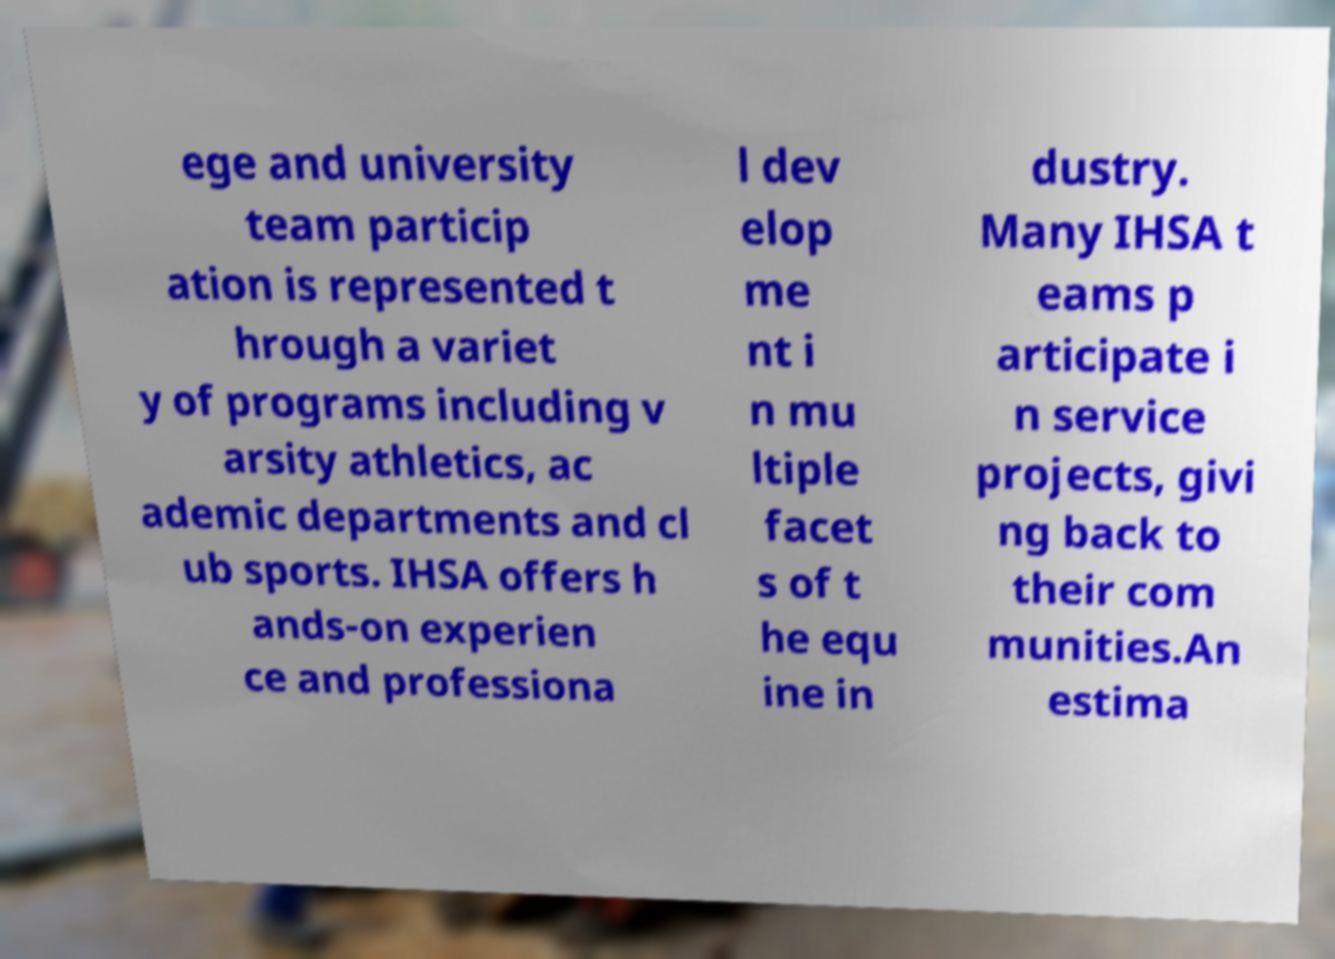Could you extract and type out the text from this image? ege and university team particip ation is represented t hrough a variet y of programs including v arsity athletics, ac ademic departments and cl ub sports. IHSA offers h ands-on experien ce and professiona l dev elop me nt i n mu ltiple facet s of t he equ ine in dustry. Many IHSA t eams p articipate i n service projects, givi ng back to their com munities.An estima 